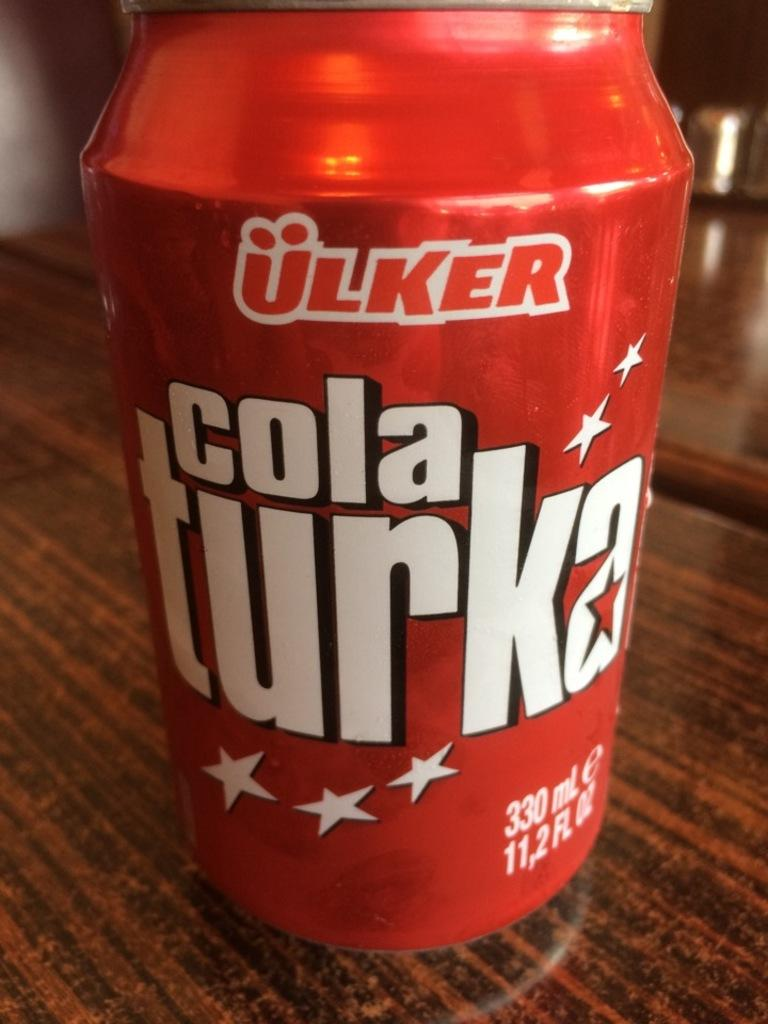<image>
Relay a brief, clear account of the picture shown. A red can of soda says cola turka and is on a wooden table. 